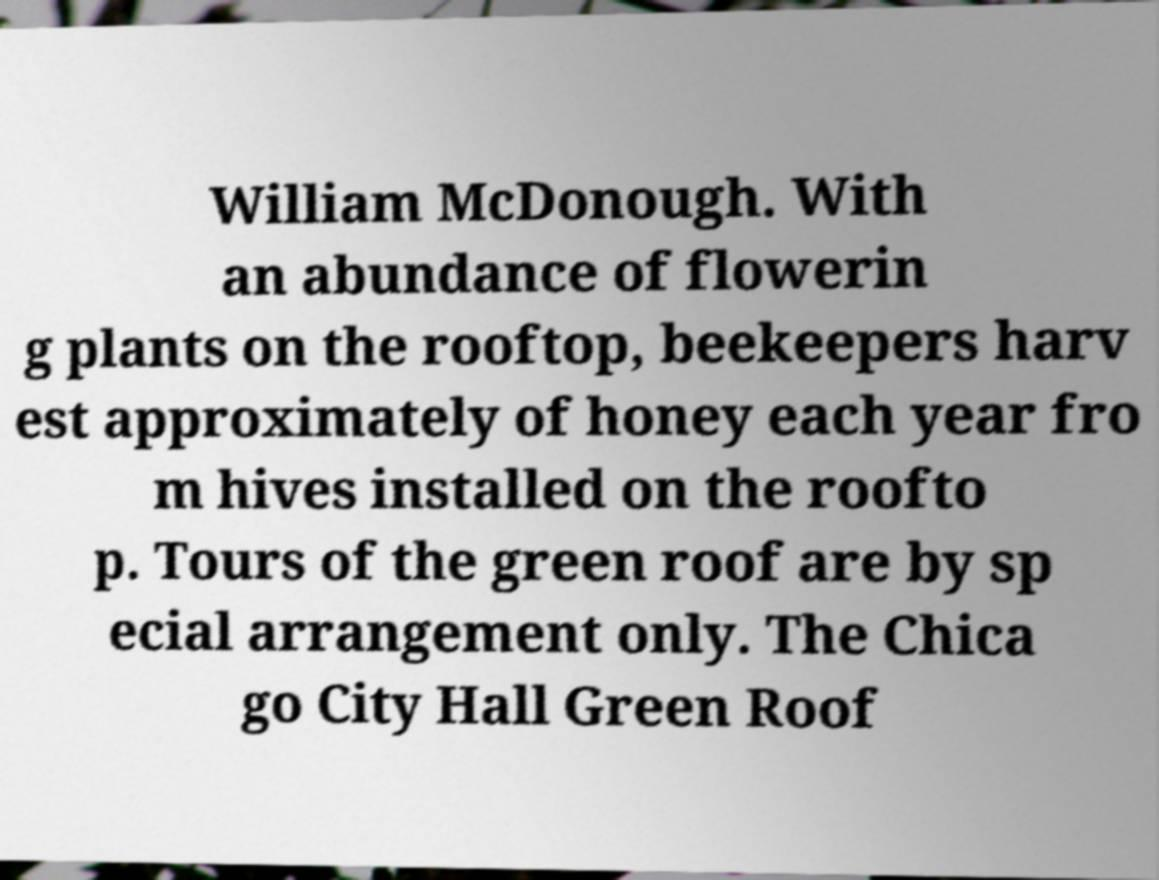Can you read and provide the text displayed in the image?This photo seems to have some interesting text. Can you extract and type it out for me? William McDonough. With an abundance of flowerin g plants on the rooftop, beekeepers harv est approximately of honey each year fro m hives installed on the roofto p. Tours of the green roof are by sp ecial arrangement only. The Chica go City Hall Green Roof 